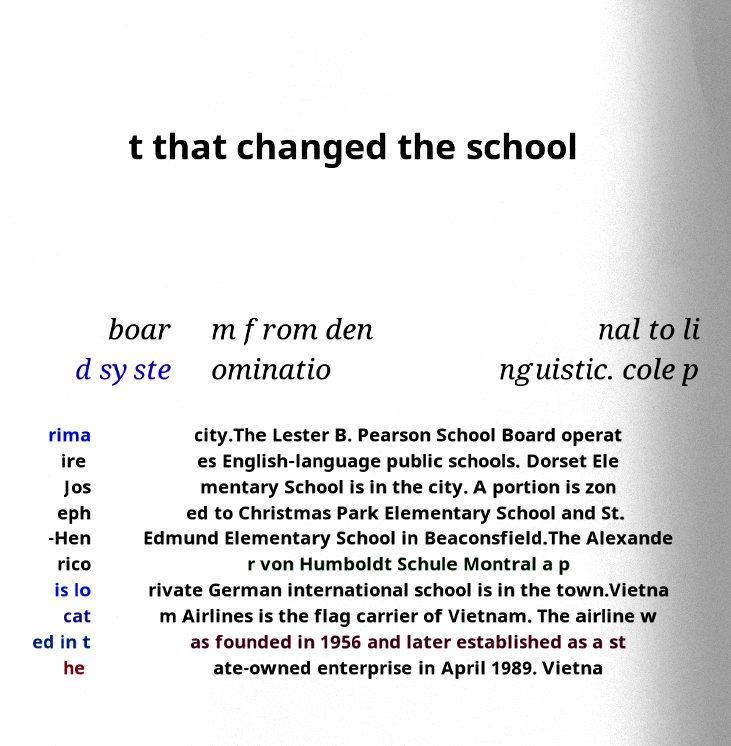Please identify and transcribe the text found in this image. t that changed the school boar d syste m from den ominatio nal to li nguistic. cole p rima ire Jos eph -Hen rico is lo cat ed in t he city.The Lester B. Pearson School Board operat es English-language public schools. Dorset Ele mentary School is in the city. A portion is zon ed to Christmas Park Elementary School and St. Edmund Elementary School in Beaconsfield.The Alexande r von Humboldt Schule Montral a p rivate German international school is in the town.Vietna m Airlines is the flag carrier of Vietnam. The airline w as founded in 1956 and later established as a st ate-owned enterprise in April 1989. Vietna 